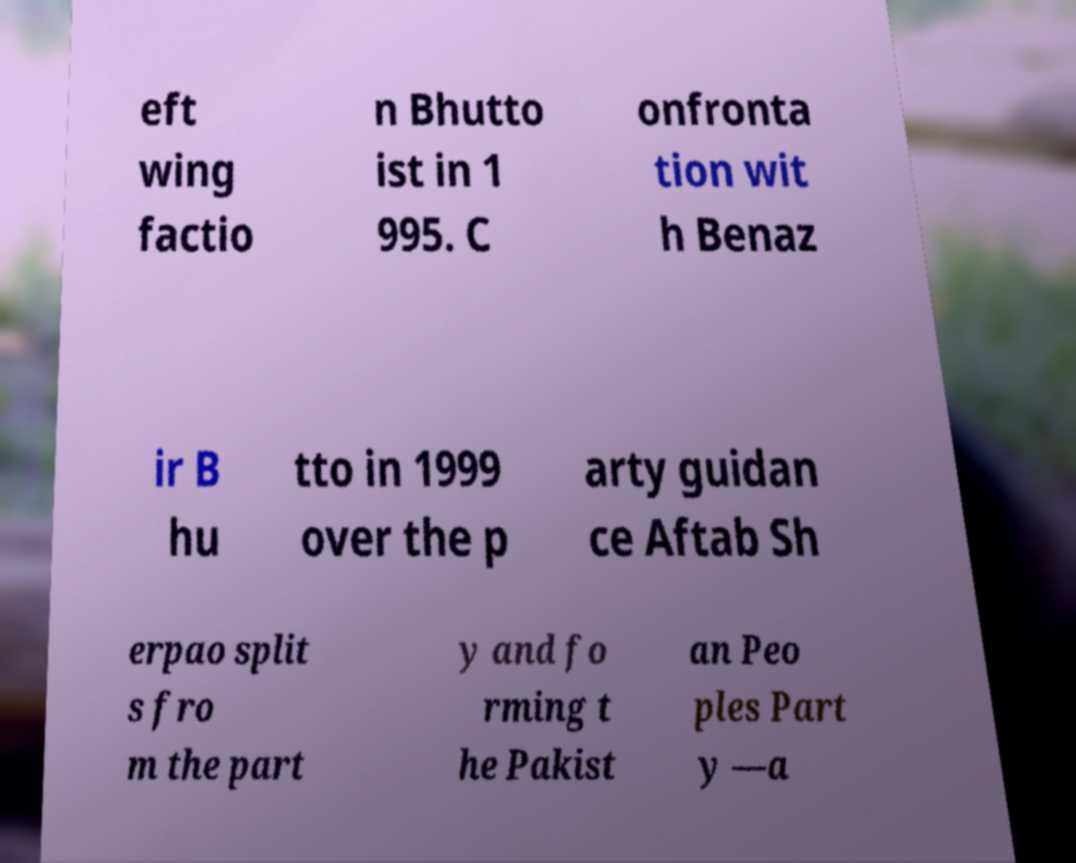Please identify and transcribe the text found in this image. eft wing factio n Bhutto ist in 1 995. C onfronta tion wit h Benaz ir B hu tto in 1999 over the p arty guidan ce Aftab Sh erpao split s fro m the part y and fo rming t he Pakist an Peo ples Part y —a 